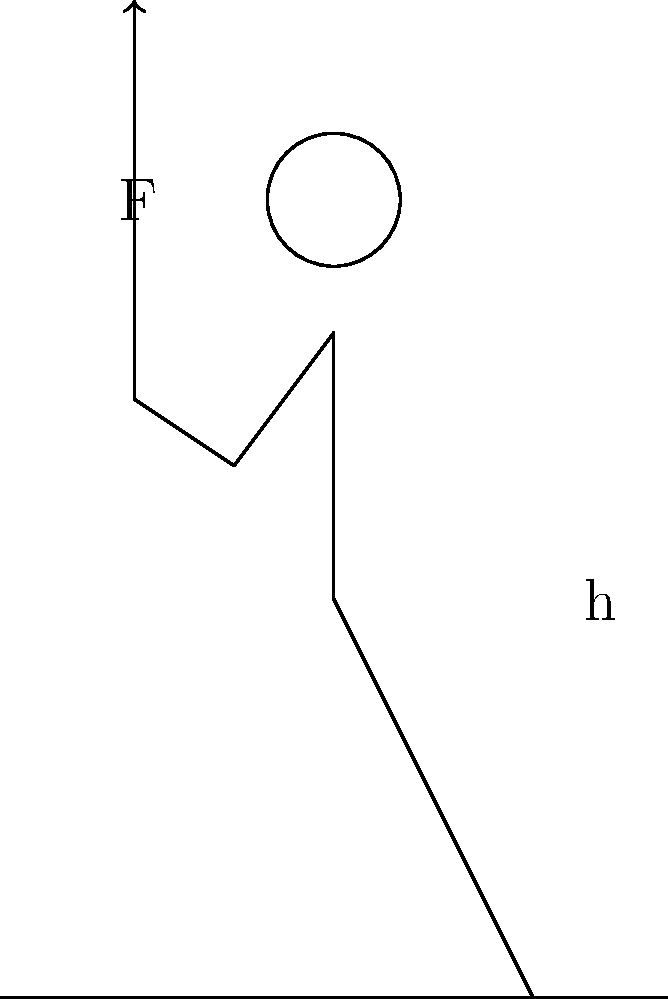In 1958, Soviet propaganda claimed that Yuri Vlasov, an Olympic weightlifter, could lift a 200 kg barbell over his head with one arm. Assuming this feat was possible, calculate the minimum work done by Vlasov to lift the barbell from shoulder height (1.5 m) to full arm extension (2.1 m). Use $g = 9.8 \text{ m/s}^2$. To calculate the minimum work done, we need to follow these steps:

1) Work is defined as force multiplied by displacement:
   $W = F \cdot d$

2) The force required to lift the barbell is equal to its weight:
   $F = m \cdot g$
   $F = 200 \text{ kg} \cdot 9.8 \text{ m/s}^2 = 1960 \text{ N}$

3) The displacement is the difference between the final and initial heights:
   $d = 2.1 \text{ m} - 1.5 \text{ m} = 0.6 \text{ m}$

4) Now we can calculate the work:
   $W = F \cdot d = 1960 \text{ N} \cdot 0.6 \text{ m} = 1176 \text{ J}$

This calculation assumes ideal conditions with no energy losses. In reality, the work done would be greater due to factors like muscle inefficiency and body movement.

It's important to note that this feat, as described in Soviet propaganda, is biomechanically impossible for a human. The world record for one-arm snatch (a similar movement) is around 101 kg, less than half of the claimed weight.
Answer: 1176 J 